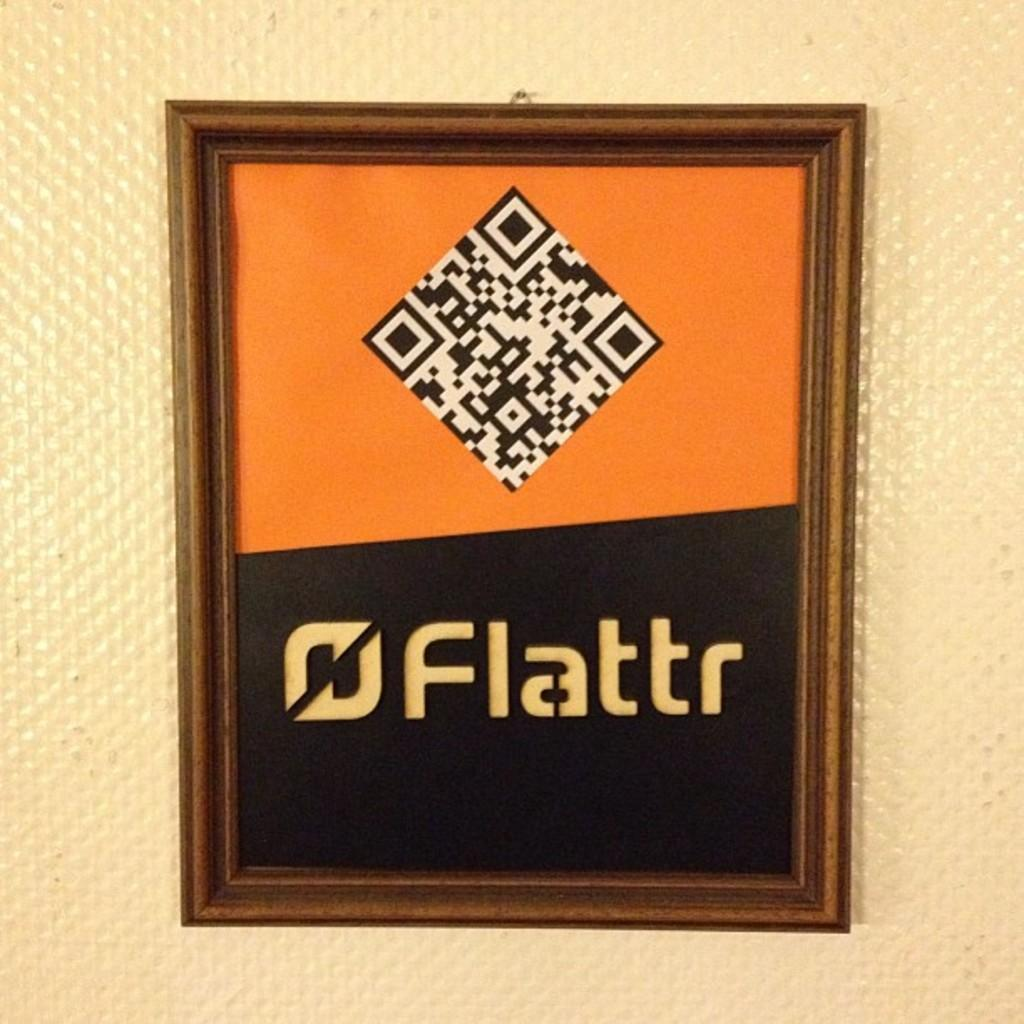What is the main subject in the center of the image? There is a photo frame in the center of the image. What is written or printed on the photo frame? There is text on the photo frame. What can be seen behind the photo frame in the image? There is a wall in the background of the image. Where is the baby sleeping in the image? There is no baby present in the image. What type of cloth is draped over the photo frame? There is no cloth draped over the photo frame in the image. 